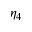<formula> <loc_0><loc_0><loc_500><loc_500>\eta _ { 4 }</formula> 